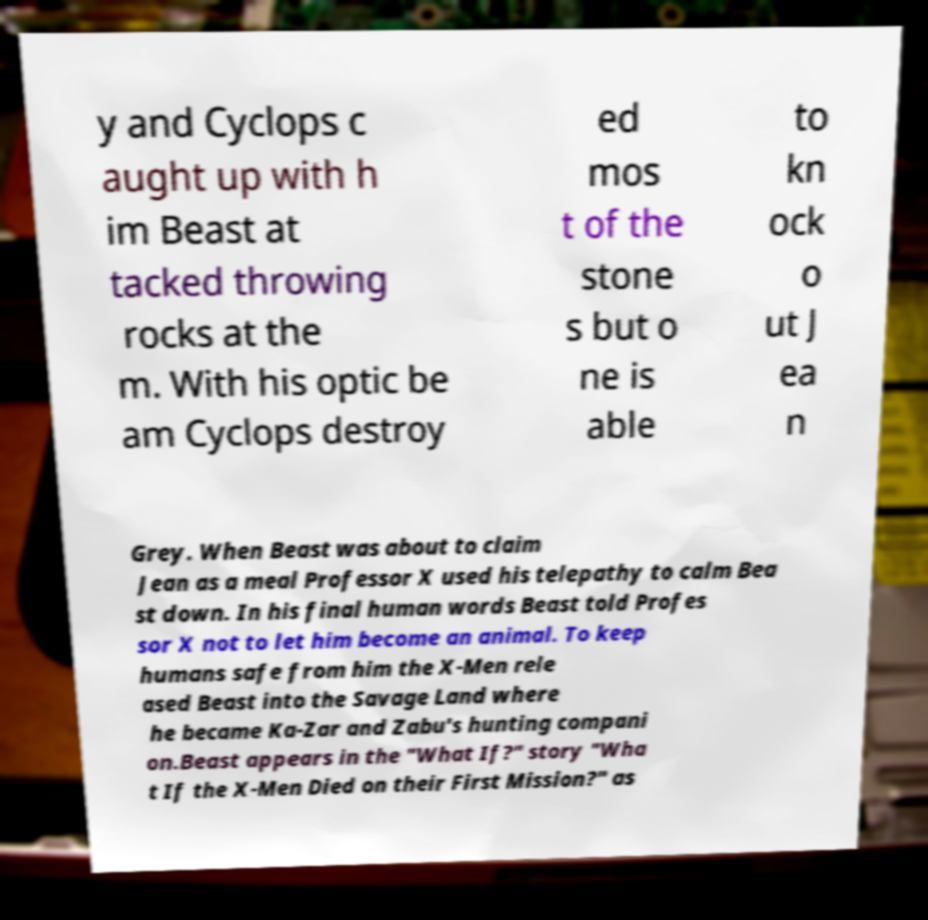Could you assist in decoding the text presented in this image and type it out clearly? y and Cyclops c aught up with h im Beast at tacked throwing rocks at the m. With his optic be am Cyclops destroy ed mos t of the stone s but o ne is able to kn ock o ut J ea n Grey. When Beast was about to claim Jean as a meal Professor X used his telepathy to calm Bea st down. In his final human words Beast told Profes sor X not to let him become an animal. To keep humans safe from him the X-Men rele ased Beast into the Savage Land where he became Ka-Zar and Zabu's hunting compani on.Beast appears in the "What If?" story "Wha t If the X-Men Died on their First Mission?" as 